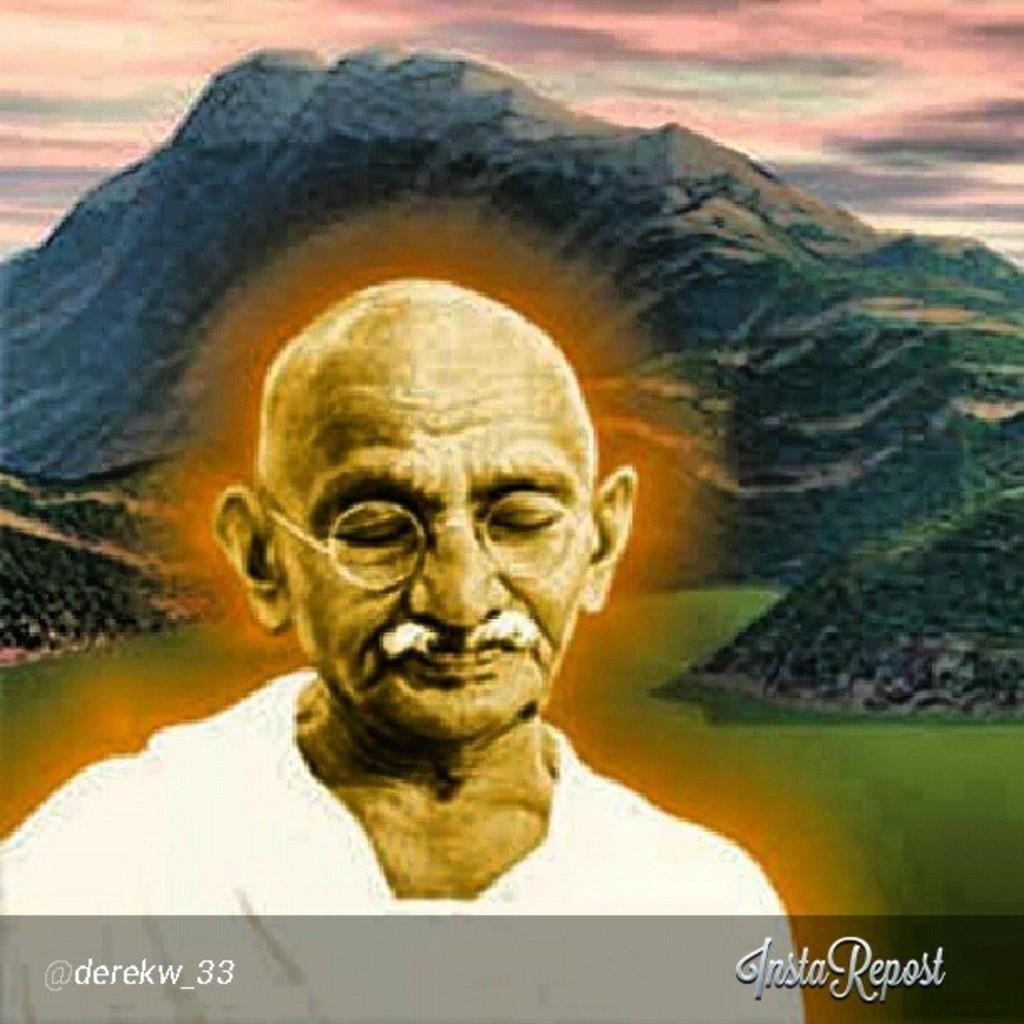Can you describe this image briefly? In this picture there is a painting of a man. In the background there are mountains and there's grass on the ground. 